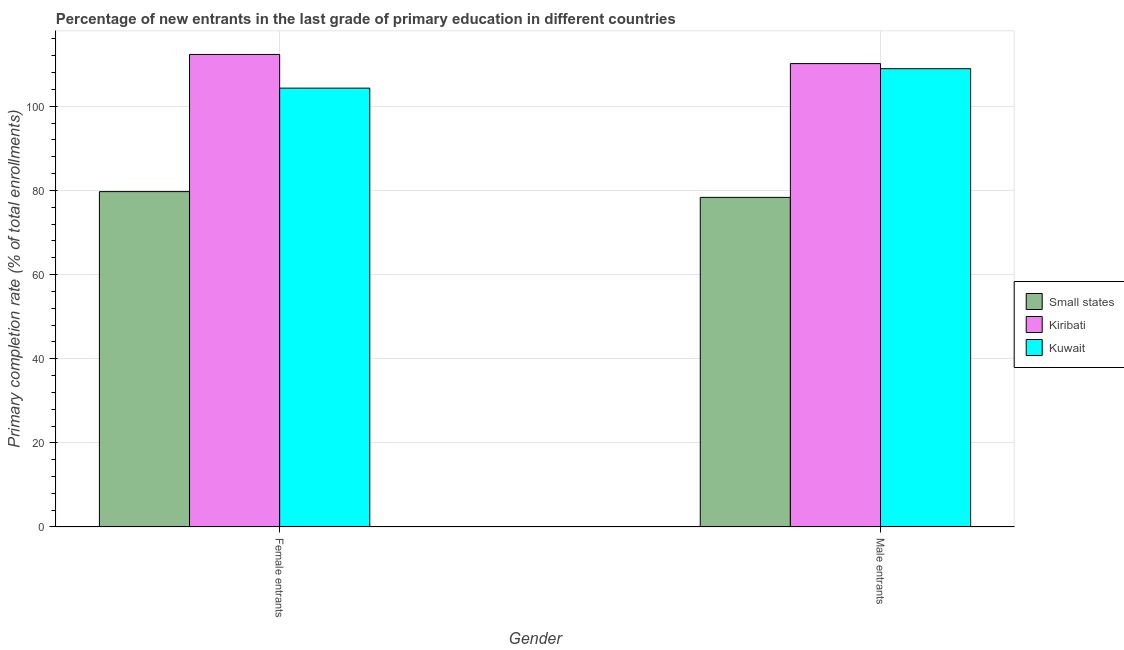How many groups of bars are there?
Provide a short and direct response. 2. Are the number of bars per tick equal to the number of legend labels?
Your answer should be compact. Yes. Are the number of bars on each tick of the X-axis equal?
Provide a succinct answer. Yes. How many bars are there on the 2nd tick from the left?
Give a very brief answer. 3. What is the label of the 1st group of bars from the left?
Give a very brief answer. Female entrants. What is the primary completion rate of female entrants in Kuwait?
Your answer should be very brief. 104.32. Across all countries, what is the maximum primary completion rate of female entrants?
Make the answer very short. 112.32. Across all countries, what is the minimum primary completion rate of female entrants?
Give a very brief answer. 79.72. In which country was the primary completion rate of male entrants maximum?
Your answer should be very brief. Kiribati. In which country was the primary completion rate of male entrants minimum?
Provide a short and direct response. Small states. What is the total primary completion rate of male entrants in the graph?
Provide a succinct answer. 297.44. What is the difference between the primary completion rate of female entrants in Kuwait and that in Small states?
Offer a terse response. 24.6. What is the difference between the primary completion rate of female entrants in Kuwait and the primary completion rate of male entrants in Small states?
Provide a succinct answer. 25.97. What is the average primary completion rate of female entrants per country?
Make the answer very short. 98.79. What is the difference between the primary completion rate of male entrants and primary completion rate of female entrants in Kuwait?
Make the answer very short. 4.62. In how many countries, is the primary completion rate of female entrants greater than 40 %?
Your response must be concise. 3. What is the ratio of the primary completion rate of female entrants in Kiribati to that in Kuwait?
Your response must be concise. 1.08. Is the primary completion rate of male entrants in Kuwait less than that in Kiribati?
Your answer should be compact. Yes. In how many countries, is the primary completion rate of female entrants greater than the average primary completion rate of female entrants taken over all countries?
Offer a terse response. 2. What does the 2nd bar from the left in Female entrants represents?
Keep it short and to the point. Kiribati. What does the 2nd bar from the right in Female entrants represents?
Make the answer very short. Kiribati. Does the graph contain grids?
Offer a terse response. Yes. Where does the legend appear in the graph?
Your answer should be very brief. Center right. What is the title of the graph?
Offer a terse response. Percentage of new entrants in the last grade of primary education in different countries. What is the label or title of the Y-axis?
Ensure brevity in your answer.  Primary completion rate (% of total enrollments). What is the Primary completion rate (% of total enrollments) of Small states in Female entrants?
Provide a succinct answer. 79.72. What is the Primary completion rate (% of total enrollments) in Kiribati in Female entrants?
Your answer should be very brief. 112.32. What is the Primary completion rate (% of total enrollments) of Kuwait in Female entrants?
Provide a short and direct response. 104.32. What is the Primary completion rate (% of total enrollments) of Small states in Male entrants?
Your answer should be very brief. 78.35. What is the Primary completion rate (% of total enrollments) in Kiribati in Male entrants?
Your response must be concise. 110.15. What is the Primary completion rate (% of total enrollments) of Kuwait in Male entrants?
Offer a very short reply. 108.94. Across all Gender, what is the maximum Primary completion rate (% of total enrollments) in Small states?
Provide a succinct answer. 79.72. Across all Gender, what is the maximum Primary completion rate (% of total enrollments) of Kiribati?
Provide a short and direct response. 112.32. Across all Gender, what is the maximum Primary completion rate (% of total enrollments) of Kuwait?
Make the answer very short. 108.94. Across all Gender, what is the minimum Primary completion rate (% of total enrollments) of Small states?
Your answer should be compact. 78.35. Across all Gender, what is the minimum Primary completion rate (% of total enrollments) of Kiribati?
Offer a very short reply. 110.15. Across all Gender, what is the minimum Primary completion rate (% of total enrollments) of Kuwait?
Offer a very short reply. 104.32. What is the total Primary completion rate (% of total enrollments) of Small states in the graph?
Provide a short and direct response. 158.07. What is the total Primary completion rate (% of total enrollments) of Kiribati in the graph?
Your response must be concise. 222.47. What is the total Primary completion rate (% of total enrollments) in Kuwait in the graph?
Your answer should be compact. 213.26. What is the difference between the Primary completion rate (% of total enrollments) in Small states in Female entrants and that in Male entrants?
Offer a terse response. 1.37. What is the difference between the Primary completion rate (% of total enrollments) in Kiribati in Female entrants and that in Male entrants?
Offer a very short reply. 2.17. What is the difference between the Primary completion rate (% of total enrollments) of Kuwait in Female entrants and that in Male entrants?
Ensure brevity in your answer.  -4.62. What is the difference between the Primary completion rate (% of total enrollments) of Small states in Female entrants and the Primary completion rate (% of total enrollments) of Kiribati in Male entrants?
Your answer should be very brief. -30.43. What is the difference between the Primary completion rate (% of total enrollments) in Small states in Female entrants and the Primary completion rate (% of total enrollments) in Kuwait in Male entrants?
Ensure brevity in your answer.  -29.22. What is the difference between the Primary completion rate (% of total enrollments) of Kiribati in Female entrants and the Primary completion rate (% of total enrollments) of Kuwait in Male entrants?
Your answer should be very brief. 3.38. What is the average Primary completion rate (% of total enrollments) of Small states per Gender?
Provide a short and direct response. 79.03. What is the average Primary completion rate (% of total enrollments) of Kiribati per Gender?
Ensure brevity in your answer.  111.24. What is the average Primary completion rate (% of total enrollments) of Kuwait per Gender?
Ensure brevity in your answer.  106.63. What is the difference between the Primary completion rate (% of total enrollments) of Small states and Primary completion rate (% of total enrollments) of Kiribati in Female entrants?
Your answer should be very brief. -32.61. What is the difference between the Primary completion rate (% of total enrollments) in Small states and Primary completion rate (% of total enrollments) in Kuwait in Female entrants?
Your response must be concise. -24.6. What is the difference between the Primary completion rate (% of total enrollments) of Kiribati and Primary completion rate (% of total enrollments) of Kuwait in Female entrants?
Give a very brief answer. 8.01. What is the difference between the Primary completion rate (% of total enrollments) of Small states and Primary completion rate (% of total enrollments) of Kiribati in Male entrants?
Provide a short and direct response. -31.8. What is the difference between the Primary completion rate (% of total enrollments) of Small states and Primary completion rate (% of total enrollments) of Kuwait in Male entrants?
Your answer should be compact. -30.59. What is the difference between the Primary completion rate (% of total enrollments) of Kiribati and Primary completion rate (% of total enrollments) of Kuwait in Male entrants?
Offer a very short reply. 1.21. What is the ratio of the Primary completion rate (% of total enrollments) of Small states in Female entrants to that in Male entrants?
Your answer should be very brief. 1.02. What is the ratio of the Primary completion rate (% of total enrollments) of Kiribati in Female entrants to that in Male entrants?
Give a very brief answer. 1.02. What is the ratio of the Primary completion rate (% of total enrollments) in Kuwait in Female entrants to that in Male entrants?
Make the answer very short. 0.96. What is the difference between the highest and the second highest Primary completion rate (% of total enrollments) in Small states?
Ensure brevity in your answer.  1.37. What is the difference between the highest and the second highest Primary completion rate (% of total enrollments) in Kiribati?
Offer a very short reply. 2.17. What is the difference between the highest and the second highest Primary completion rate (% of total enrollments) of Kuwait?
Your answer should be very brief. 4.62. What is the difference between the highest and the lowest Primary completion rate (% of total enrollments) of Small states?
Provide a succinct answer. 1.37. What is the difference between the highest and the lowest Primary completion rate (% of total enrollments) in Kiribati?
Give a very brief answer. 2.17. What is the difference between the highest and the lowest Primary completion rate (% of total enrollments) in Kuwait?
Provide a succinct answer. 4.62. 